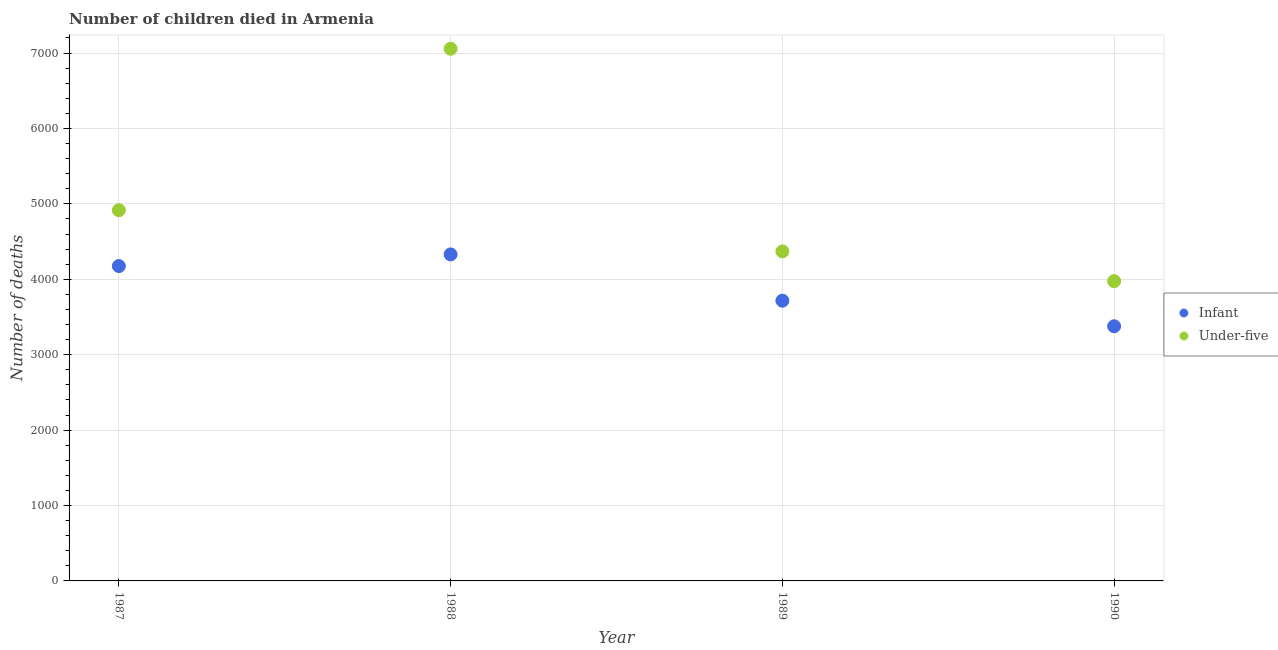Is the number of dotlines equal to the number of legend labels?
Your answer should be compact. Yes. What is the number of under-five deaths in 1989?
Ensure brevity in your answer.  4370. Across all years, what is the maximum number of infant deaths?
Make the answer very short. 4330. Across all years, what is the minimum number of under-five deaths?
Keep it short and to the point. 3975. In which year was the number of under-five deaths maximum?
Provide a succinct answer. 1988. What is the total number of infant deaths in the graph?
Keep it short and to the point. 1.56e+04. What is the difference between the number of infant deaths in 1988 and that in 1990?
Offer a terse response. 953. What is the difference between the number of infant deaths in 1987 and the number of under-five deaths in 1988?
Provide a succinct answer. -2882. What is the average number of infant deaths per year?
Your answer should be very brief. 3899.5. In the year 1987, what is the difference between the number of under-five deaths and number of infant deaths?
Provide a succinct answer. 741. In how many years, is the number of infant deaths greater than 3400?
Your response must be concise. 3. What is the ratio of the number of under-five deaths in 1987 to that in 1988?
Provide a succinct answer. 0.7. Is the number of under-five deaths in 1987 less than that in 1990?
Offer a terse response. No. What is the difference between the highest and the second highest number of under-five deaths?
Offer a terse response. 2141. What is the difference between the highest and the lowest number of under-five deaths?
Provide a succinct answer. 3082. In how many years, is the number of infant deaths greater than the average number of infant deaths taken over all years?
Offer a terse response. 2. Is the number of under-five deaths strictly less than the number of infant deaths over the years?
Give a very brief answer. No. How many dotlines are there?
Offer a very short reply. 2. How many years are there in the graph?
Ensure brevity in your answer.  4. What is the difference between two consecutive major ticks on the Y-axis?
Your answer should be very brief. 1000. Are the values on the major ticks of Y-axis written in scientific E-notation?
Your response must be concise. No. Does the graph contain any zero values?
Offer a terse response. No. Does the graph contain grids?
Provide a short and direct response. Yes. How many legend labels are there?
Your response must be concise. 2. How are the legend labels stacked?
Ensure brevity in your answer.  Vertical. What is the title of the graph?
Offer a terse response. Number of children died in Armenia. Does "Working only" appear as one of the legend labels in the graph?
Offer a very short reply. No. What is the label or title of the X-axis?
Make the answer very short. Year. What is the label or title of the Y-axis?
Your answer should be compact. Number of deaths. What is the Number of deaths of Infant in 1987?
Offer a very short reply. 4175. What is the Number of deaths in Under-five in 1987?
Keep it short and to the point. 4916. What is the Number of deaths in Infant in 1988?
Offer a terse response. 4330. What is the Number of deaths of Under-five in 1988?
Your answer should be very brief. 7057. What is the Number of deaths in Infant in 1989?
Give a very brief answer. 3716. What is the Number of deaths in Under-five in 1989?
Ensure brevity in your answer.  4370. What is the Number of deaths in Infant in 1990?
Ensure brevity in your answer.  3377. What is the Number of deaths of Under-five in 1990?
Your answer should be very brief. 3975. Across all years, what is the maximum Number of deaths in Infant?
Offer a terse response. 4330. Across all years, what is the maximum Number of deaths of Under-five?
Keep it short and to the point. 7057. Across all years, what is the minimum Number of deaths of Infant?
Your response must be concise. 3377. Across all years, what is the minimum Number of deaths in Under-five?
Offer a terse response. 3975. What is the total Number of deaths in Infant in the graph?
Provide a short and direct response. 1.56e+04. What is the total Number of deaths in Under-five in the graph?
Offer a very short reply. 2.03e+04. What is the difference between the Number of deaths in Infant in 1987 and that in 1988?
Provide a succinct answer. -155. What is the difference between the Number of deaths in Under-five in 1987 and that in 1988?
Provide a succinct answer. -2141. What is the difference between the Number of deaths in Infant in 1987 and that in 1989?
Provide a short and direct response. 459. What is the difference between the Number of deaths of Under-five in 1987 and that in 1989?
Offer a terse response. 546. What is the difference between the Number of deaths of Infant in 1987 and that in 1990?
Give a very brief answer. 798. What is the difference between the Number of deaths in Under-five in 1987 and that in 1990?
Offer a very short reply. 941. What is the difference between the Number of deaths of Infant in 1988 and that in 1989?
Provide a short and direct response. 614. What is the difference between the Number of deaths in Under-five in 1988 and that in 1989?
Provide a succinct answer. 2687. What is the difference between the Number of deaths of Infant in 1988 and that in 1990?
Your response must be concise. 953. What is the difference between the Number of deaths of Under-five in 1988 and that in 1990?
Provide a succinct answer. 3082. What is the difference between the Number of deaths in Infant in 1989 and that in 1990?
Make the answer very short. 339. What is the difference between the Number of deaths of Under-five in 1989 and that in 1990?
Keep it short and to the point. 395. What is the difference between the Number of deaths in Infant in 1987 and the Number of deaths in Under-five in 1988?
Keep it short and to the point. -2882. What is the difference between the Number of deaths in Infant in 1987 and the Number of deaths in Under-five in 1989?
Provide a short and direct response. -195. What is the difference between the Number of deaths in Infant in 1987 and the Number of deaths in Under-five in 1990?
Offer a very short reply. 200. What is the difference between the Number of deaths of Infant in 1988 and the Number of deaths of Under-five in 1989?
Offer a terse response. -40. What is the difference between the Number of deaths in Infant in 1988 and the Number of deaths in Under-five in 1990?
Ensure brevity in your answer.  355. What is the difference between the Number of deaths in Infant in 1989 and the Number of deaths in Under-five in 1990?
Provide a short and direct response. -259. What is the average Number of deaths in Infant per year?
Your response must be concise. 3899.5. What is the average Number of deaths in Under-five per year?
Ensure brevity in your answer.  5079.5. In the year 1987, what is the difference between the Number of deaths in Infant and Number of deaths in Under-five?
Make the answer very short. -741. In the year 1988, what is the difference between the Number of deaths of Infant and Number of deaths of Under-five?
Offer a very short reply. -2727. In the year 1989, what is the difference between the Number of deaths in Infant and Number of deaths in Under-five?
Provide a succinct answer. -654. In the year 1990, what is the difference between the Number of deaths of Infant and Number of deaths of Under-five?
Offer a terse response. -598. What is the ratio of the Number of deaths in Infant in 1987 to that in 1988?
Ensure brevity in your answer.  0.96. What is the ratio of the Number of deaths in Under-five in 1987 to that in 1988?
Provide a succinct answer. 0.7. What is the ratio of the Number of deaths of Infant in 1987 to that in 1989?
Offer a very short reply. 1.12. What is the ratio of the Number of deaths in Under-five in 1987 to that in 1989?
Your answer should be very brief. 1.12. What is the ratio of the Number of deaths of Infant in 1987 to that in 1990?
Your answer should be very brief. 1.24. What is the ratio of the Number of deaths of Under-five in 1987 to that in 1990?
Your response must be concise. 1.24. What is the ratio of the Number of deaths of Infant in 1988 to that in 1989?
Make the answer very short. 1.17. What is the ratio of the Number of deaths in Under-five in 1988 to that in 1989?
Keep it short and to the point. 1.61. What is the ratio of the Number of deaths of Infant in 1988 to that in 1990?
Offer a terse response. 1.28. What is the ratio of the Number of deaths of Under-five in 1988 to that in 1990?
Make the answer very short. 1.78. What is the ratio of the Number of deaths in Infant in 1989 to that in 1990?
Your answer should be very brief. 1.1. What is the ratio of the Number of deaths in Under-five in 1989 to that in 1990?
Offer a very short reply. 1.1. What is the difference between the highest and the second highest Number of deaths of Infant?
Provide a succinct answer. 155. What is the difference between the highest and the second highest Number of deaths of Under-five?
Offer a terse response. 2141. What is the difference between the highest and the lowest Number of deaths of Infant?
Offer a terse response. 953. What is the difference between the highest and the lowest Number of deaths of Under-five?
Your answer should be compact. 3082. 